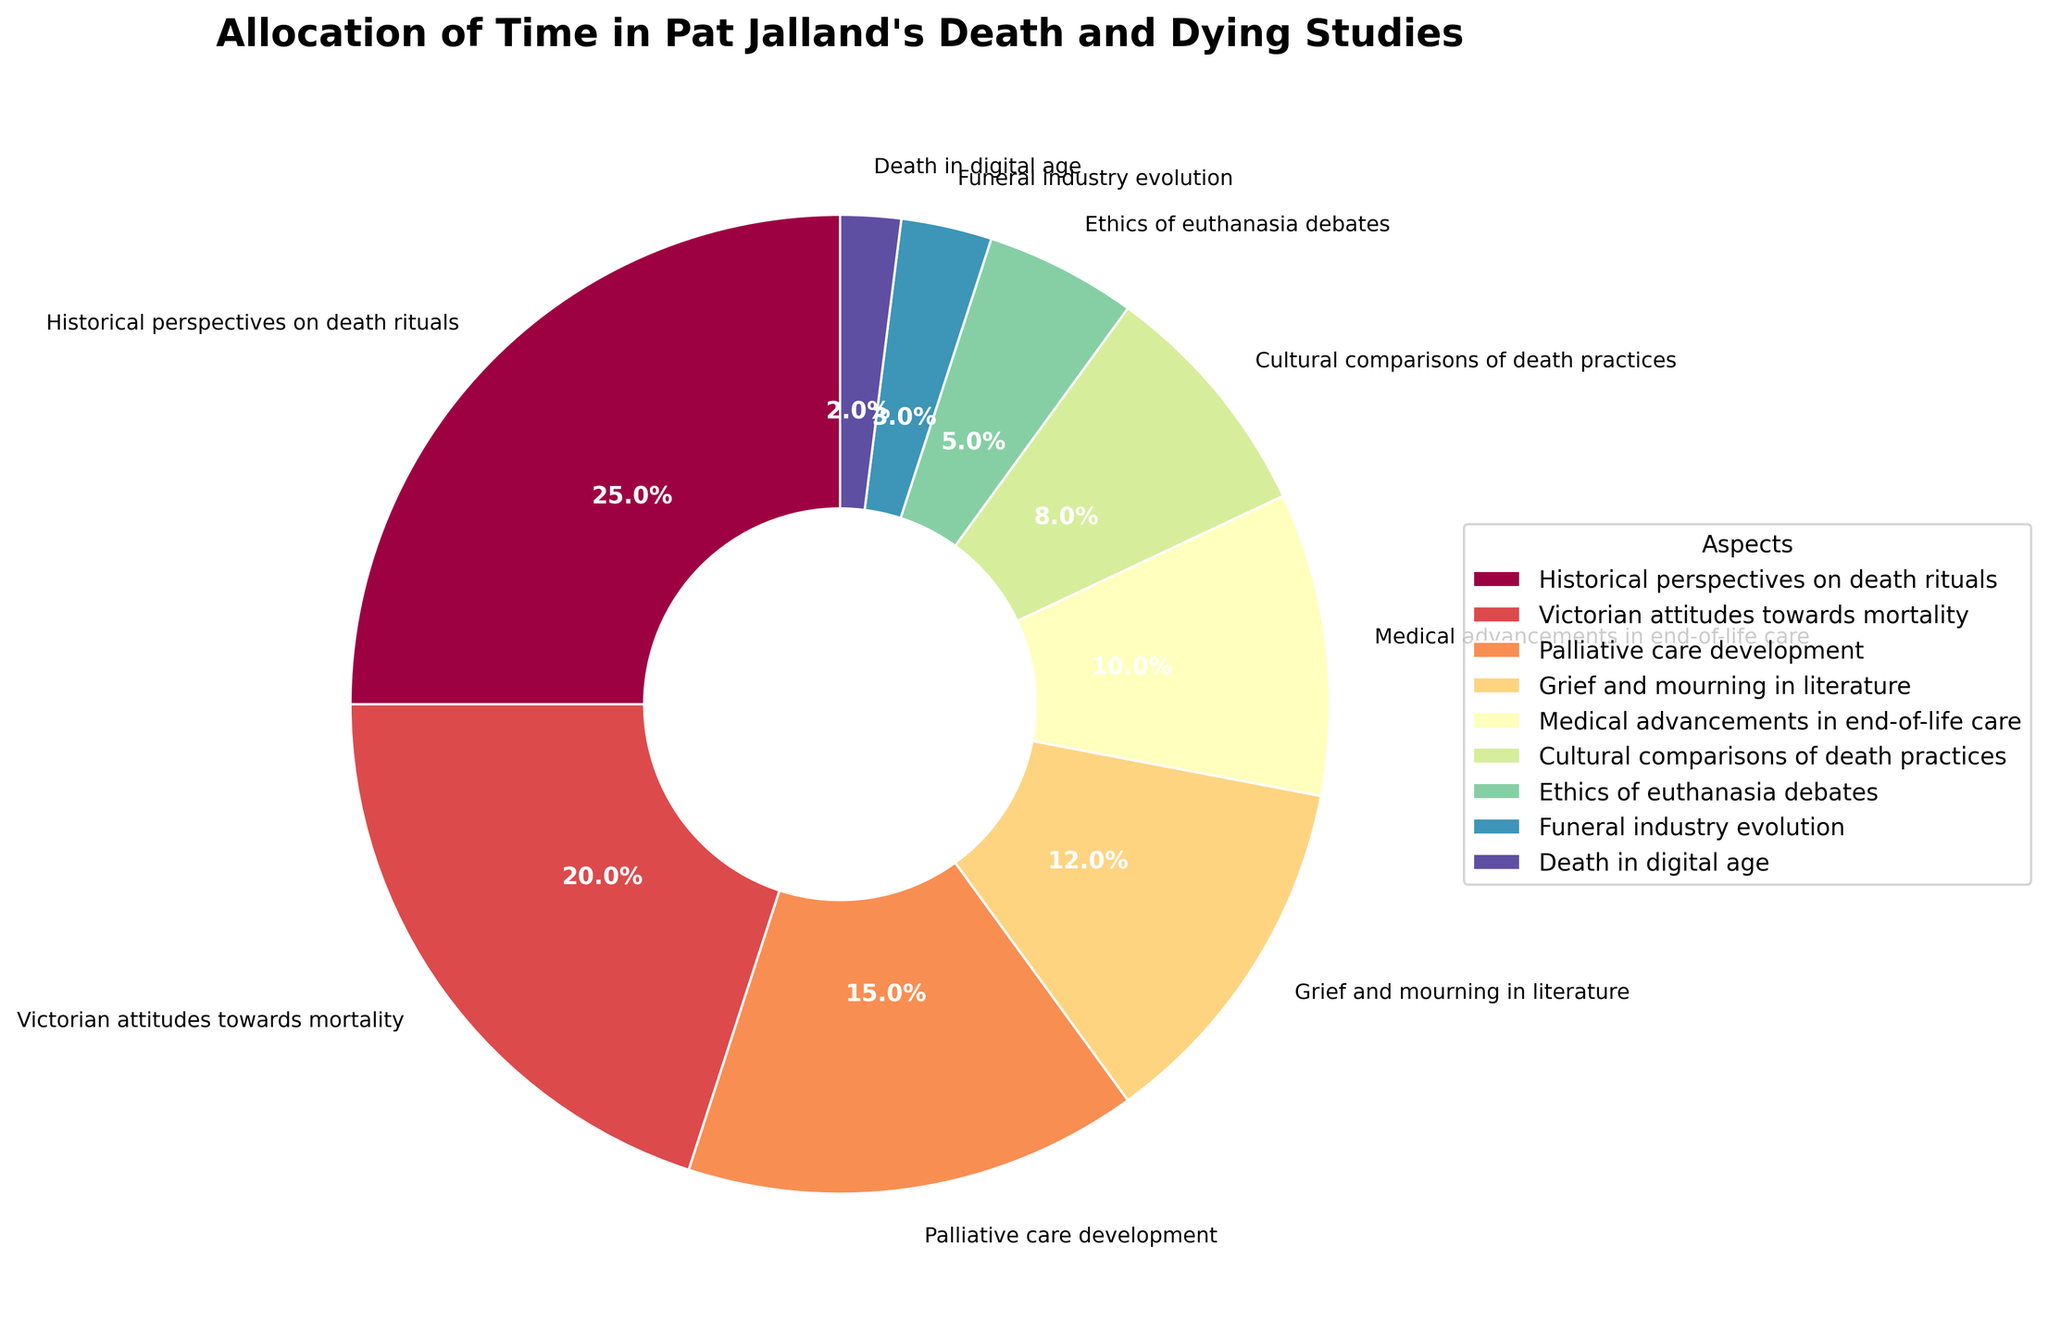What's the total percentage allocated to Historical perspectives on death rituals and Victorian attitudes towards mortality? Add the percentages for Historical perspectives on death rituals (25%) and Victorian attitudes towards mortality (20%): 25 + 20 = 45%
Answer: 45% Which aspect has the lowest allocation of time and what is its percentage? From the figure, identify the aspect with the smallest wedge. "Death in digital age" has the smallest percentage slice, which is 2%
Answer: Death in digital age, 2% How much more time is allocated to Grief and mourning in literature compared to Death in the digital age? Subtract the percentage for Death in the digital age (2%) from Grief and mourning in literature (12%): 12 - 2 = 10%
Answer: 10% What is the combined percentage for aspects related to medical care (Palliative care development and Medical advancements in end-of-life care)? Add the percentages of Palliative care development (15%) and Medical advancements in end-of-life care (10%): 15 + 10 = 25%
Answer: 25% List the three aspects with the highest allocation of time in descending order along with their percentages. Identify the top three largest slices in the pie chart: Historical perspectives on death rituals (25%), Victorian attitudes towards mortality (20%), and Palliative care development (15%).
Answer: Historical perspectives on death rituals, 25%; Victorian attitudes towards mortality, 20%; Palliative care development, 15% If combined, would the time allocated to Ethics of euthanasia debates and Funeral industry evolution exceed the time for Cultural comparisons of death practices? Add the percentages of Ethics of euthanasia debates (5%) and Funeral industry evolution (3%) to see if it exceeds Cultural comparisons of death practices (8%): 5 + 3 = 8% which equals 8%.
Answer: No, it equals, not exceeds Which aspect has a percentage closest to the average of all the percentages shown? Calculate the average: (25 + 20 + 15 + 12 + 10 + 8 + 5 + 3 + 2) / 9 = 100/9 ≈ 11.1%. Grief and mourning in literature is closest to this average with 12%
Answer: Grief and mourning in literature, 12% How many aspects have an allocation of 10% or more? Identify and count aspects with allocations of 10% or more (Historical perspectives on death rituals, Victorian attitudes towards mortality, Palliative care development, Grief and mourning in literature, Medical advancements in end-of-life care): There are 5 such aspects.
Answer: 5 Compare the combined percentage of Ethics of euthanasia debates and Death in the digital age to Funeral industry evolution. Which is larger? Add the percentages of Ethics of euthanasia debates (5%) and Death in the digital age (2%): 5 + 2 = 7%. Compare to Funeral industry evolution (3%): 7% is larger than 3%.
Answer: Ethics of euthanasia debates and Death in the digital age, 7% What color is used for the wedge representing Victorian attitudes towards mortality, and how does it relate to the Spectral colormap? The color for each aspect is derived from the Spectral colormap, typically featuring a range of colors from red to violet. Victorian attitudes towards mortality would therefore occupy a color relatively early in the sequence, possibly orange or red, recognizable as the second or third largest segment.
Answer: Likely orange or red 